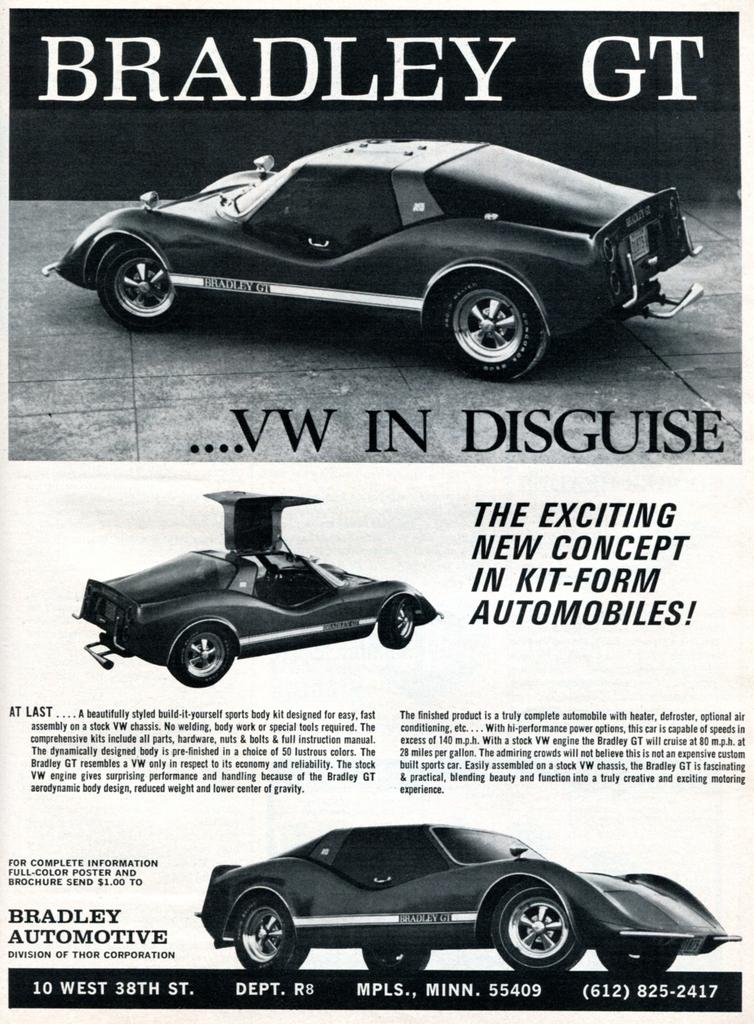What is featured in the image? There is a poster in the image. What type of images are on the poster? The poster contains images of cars. Are there any words or letters on the poster? Yes, there is writing on the poster. What type of plant is growing next to the poster in the image? There is no plant visible in the image; it only features a poster with images of cars and writing. 